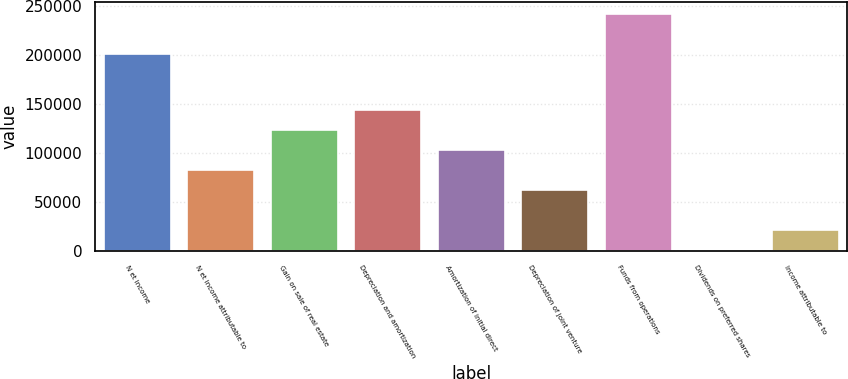Convert chart. <chart><loc_0><loc_0><loc_500><loc_500><bar_chart><fcel>N et income<fcel>N et income attributable to<fcel>Gain on sale of real estate<fcel>Depreciation and amortization<fcel>Amortization of initial direct<fcel>Depreciation of joint venture<fcel>Funds from operations<fcel>Dividends on preferred shares<fcel>Income attributable to<nl><fcel>201127<fcel>82684.4<fcel>123806<fcel>144366<fcel>103245<fcel>62123.8<fcel>242248<fcel>442<fcel>21002.6<nl></chart> 